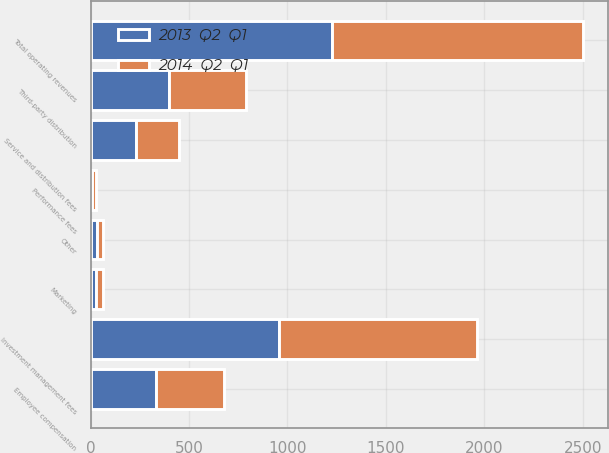<chart> <loc_0><loc_0><loc_500><loc_500><stacked_bar_chart><ecel><fcel>Investment management fees<fcel>Service and distribution fees<fcel>Performance fees<fcel>Other<fcel>Total operating revenues<fcel>Employee compensation<fcel>Third-party distribution<fcel>Marketing<nl><fcel>2014  Q2  Q1<fcel>1009.5<fcel>217.7<fcel>16.8<fcel>32.7<fcel>1276.7<fcel>345.7<fcel>394.5<fcel>31.9<nl><fcel>2013  Q2  Q1<fcel>955.1<fcel>230.1<fcel>8.7<fcel>31.2<fcel>1225.1<fcel>333.4<fcel>396.2<fcel>30<nl></chart> 